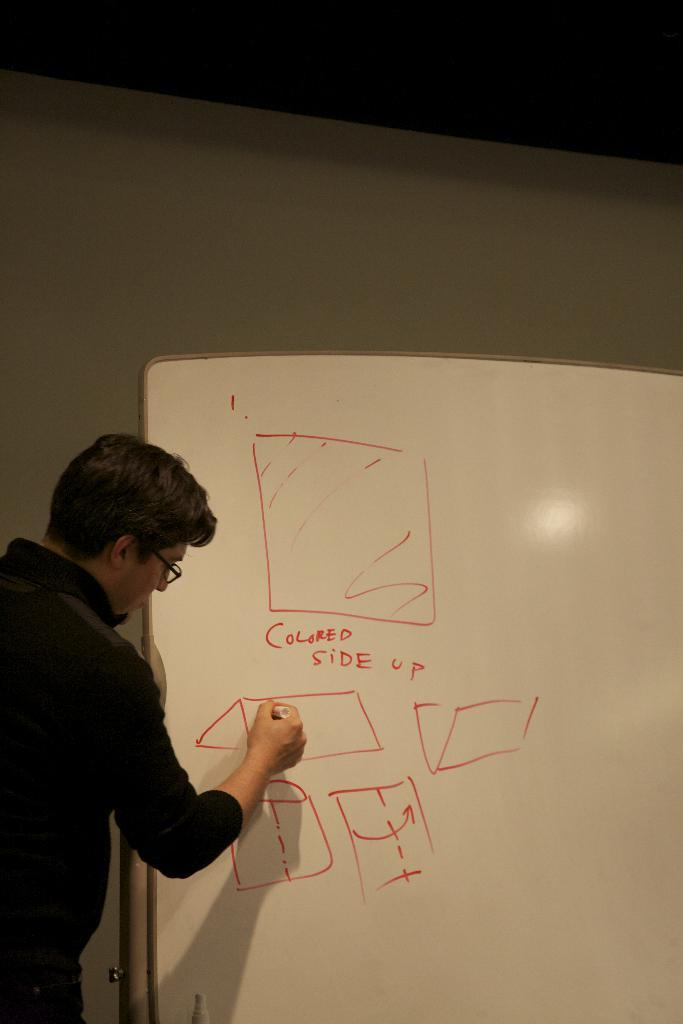Who is the main subject in the image? There is a man in the image. What is the man doing in the image? The man is writing on a board. What color is the sketch he is using? The man is using a red sketch to write. What can be seen behind the board in the image? There is a wall behind the board. How many women are present in the image? There are no women present in the image; it features a man writing on a board. 